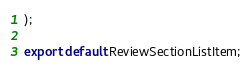Convert code to text. <code><loc_0><loc_0><loc_500><loc_500><_TypeScript_>);

export default ReviewSectionListItem;
</code> 